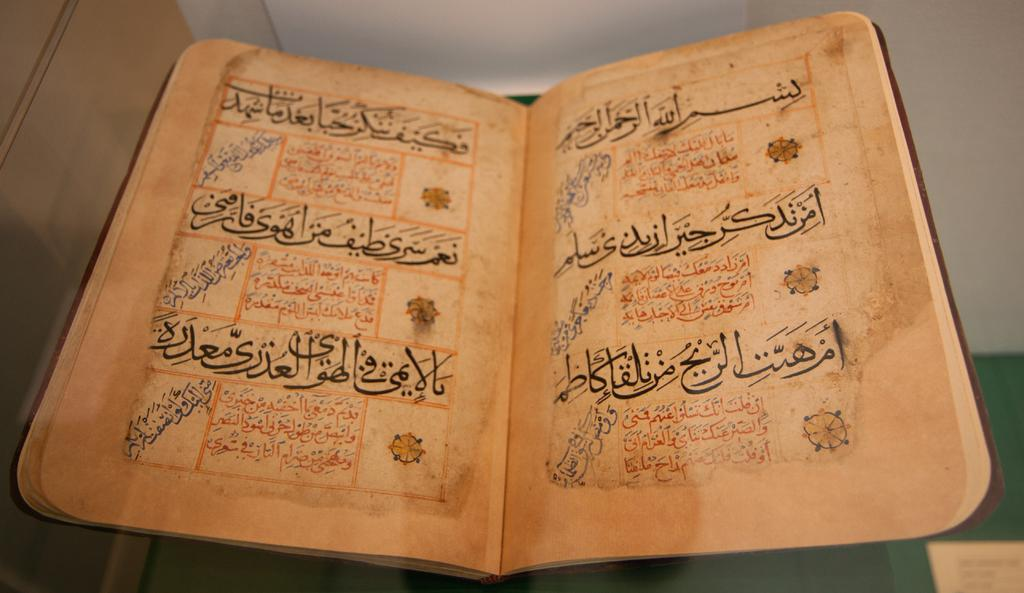<image>
Share a concise interpretation of the image provided. A age worn book with text in an Asian language is opened. 